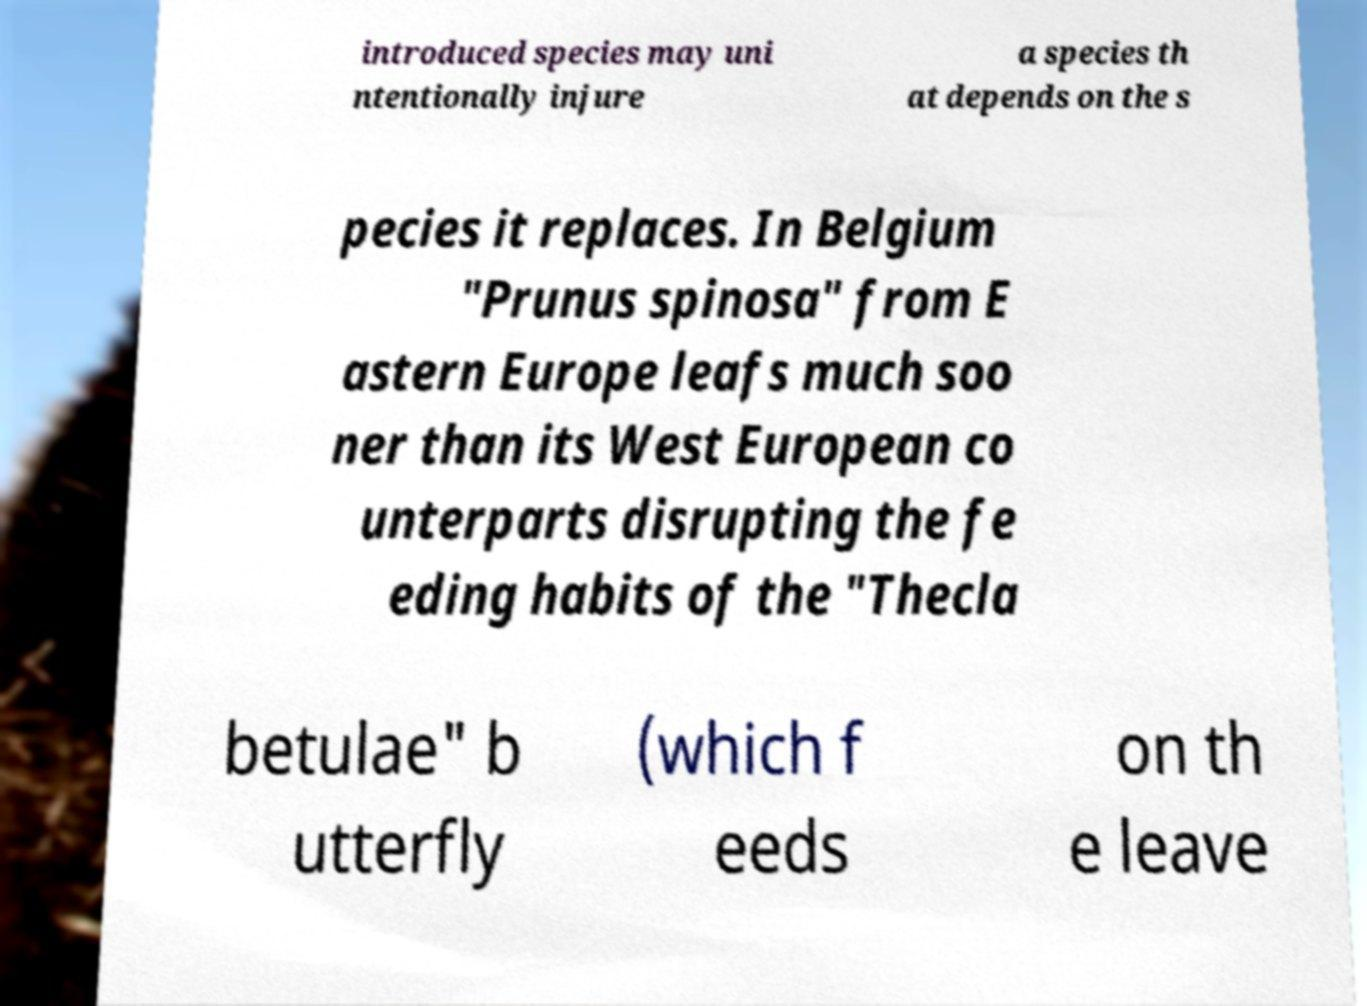Could you extract and type out the text from this image? introduced species may uni ntentionally injure a species th at depends on the s pecies it replaces. In Belgium "Prunus spinosa" from E astern Europe leafs much soo ner than its West European co unterparts disrupting the fe eding habits of the "Thecla betulae" b utterfly (which f eeds on th e leave 